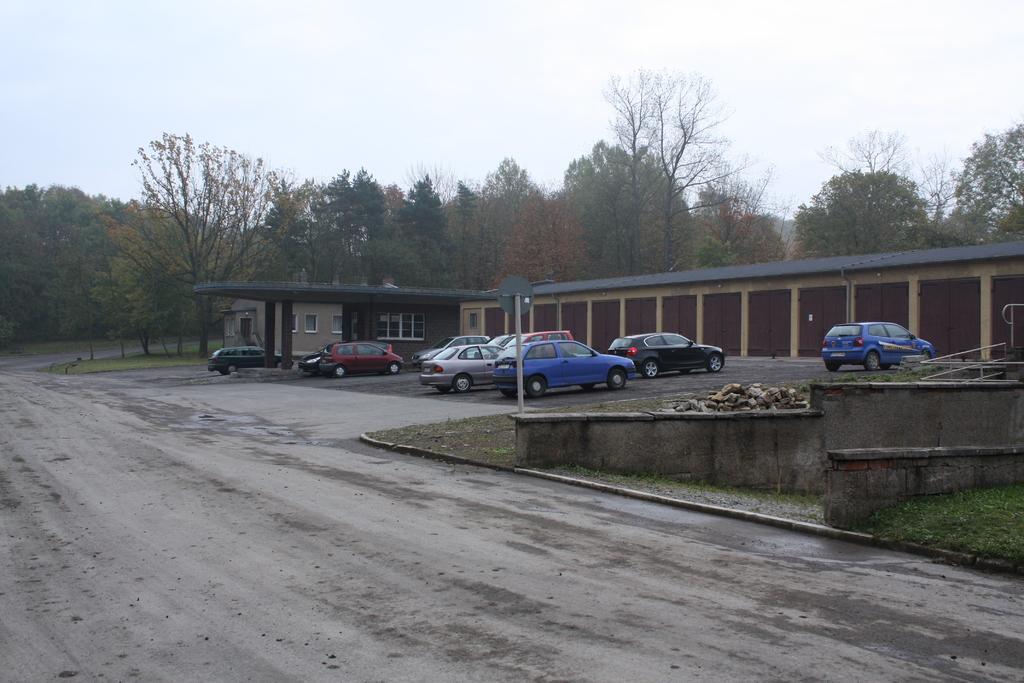Could you give a brief overview of what you see in this image? There is a road at the bottom of this image. We can see cars, trees and a building in the middle of this image and the sky at the top of this image. 